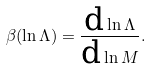Convert formula to latex. <formula><loc_0><loc_0><loc_500><loc_500>\beta ( \ln \Lambda ) = \frac { \text {d} \ln \Lambda } { \text {d} \ln M } .</formula> 